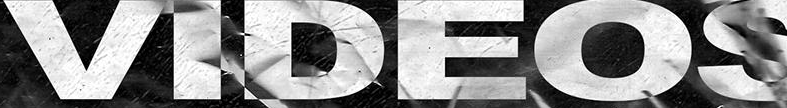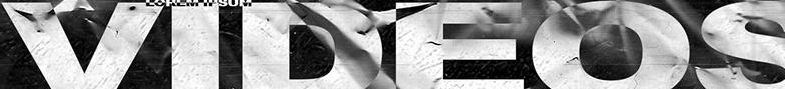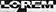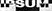What text appears in these images from left to right, separated by a semicolon? VIDEOS; VIDEOS; LOPEM; IPSUM 